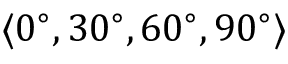Convert formula to latex. <formula><loc_0><loc_0><loc_500><loc_500>\langle 0 ^ { \circ } , 3 0 ^ { \circ } , 6 0 ^ { \circ } , 9 0 ^ { \circ } \rangle</formula> 